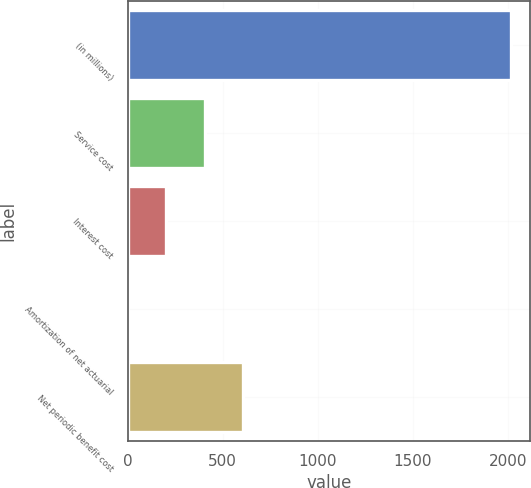Convert chart. <chart><loc_0><loc_0><loc_500><loc_500><bar_chart><fcel>(in millions)<fcel>Service cost<fcel>Interest cost<fcel>Amortization of net actuarial<fcel>Net periodic benefit cost<nl><fcel>2014<fcel>405.04<fcel>203.92<fcel>2.8<fcel>606.16<nl></chart> 